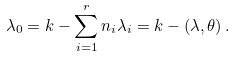<formula> <loc_0><loc_0><loc_500><loc_500>\lambda _ { 0 } = k - \sum _ { i = 1 } ^ { r } n _ { i } \lambda _ { i } = k - ( \lambda , \theta ) \, .</formula> 